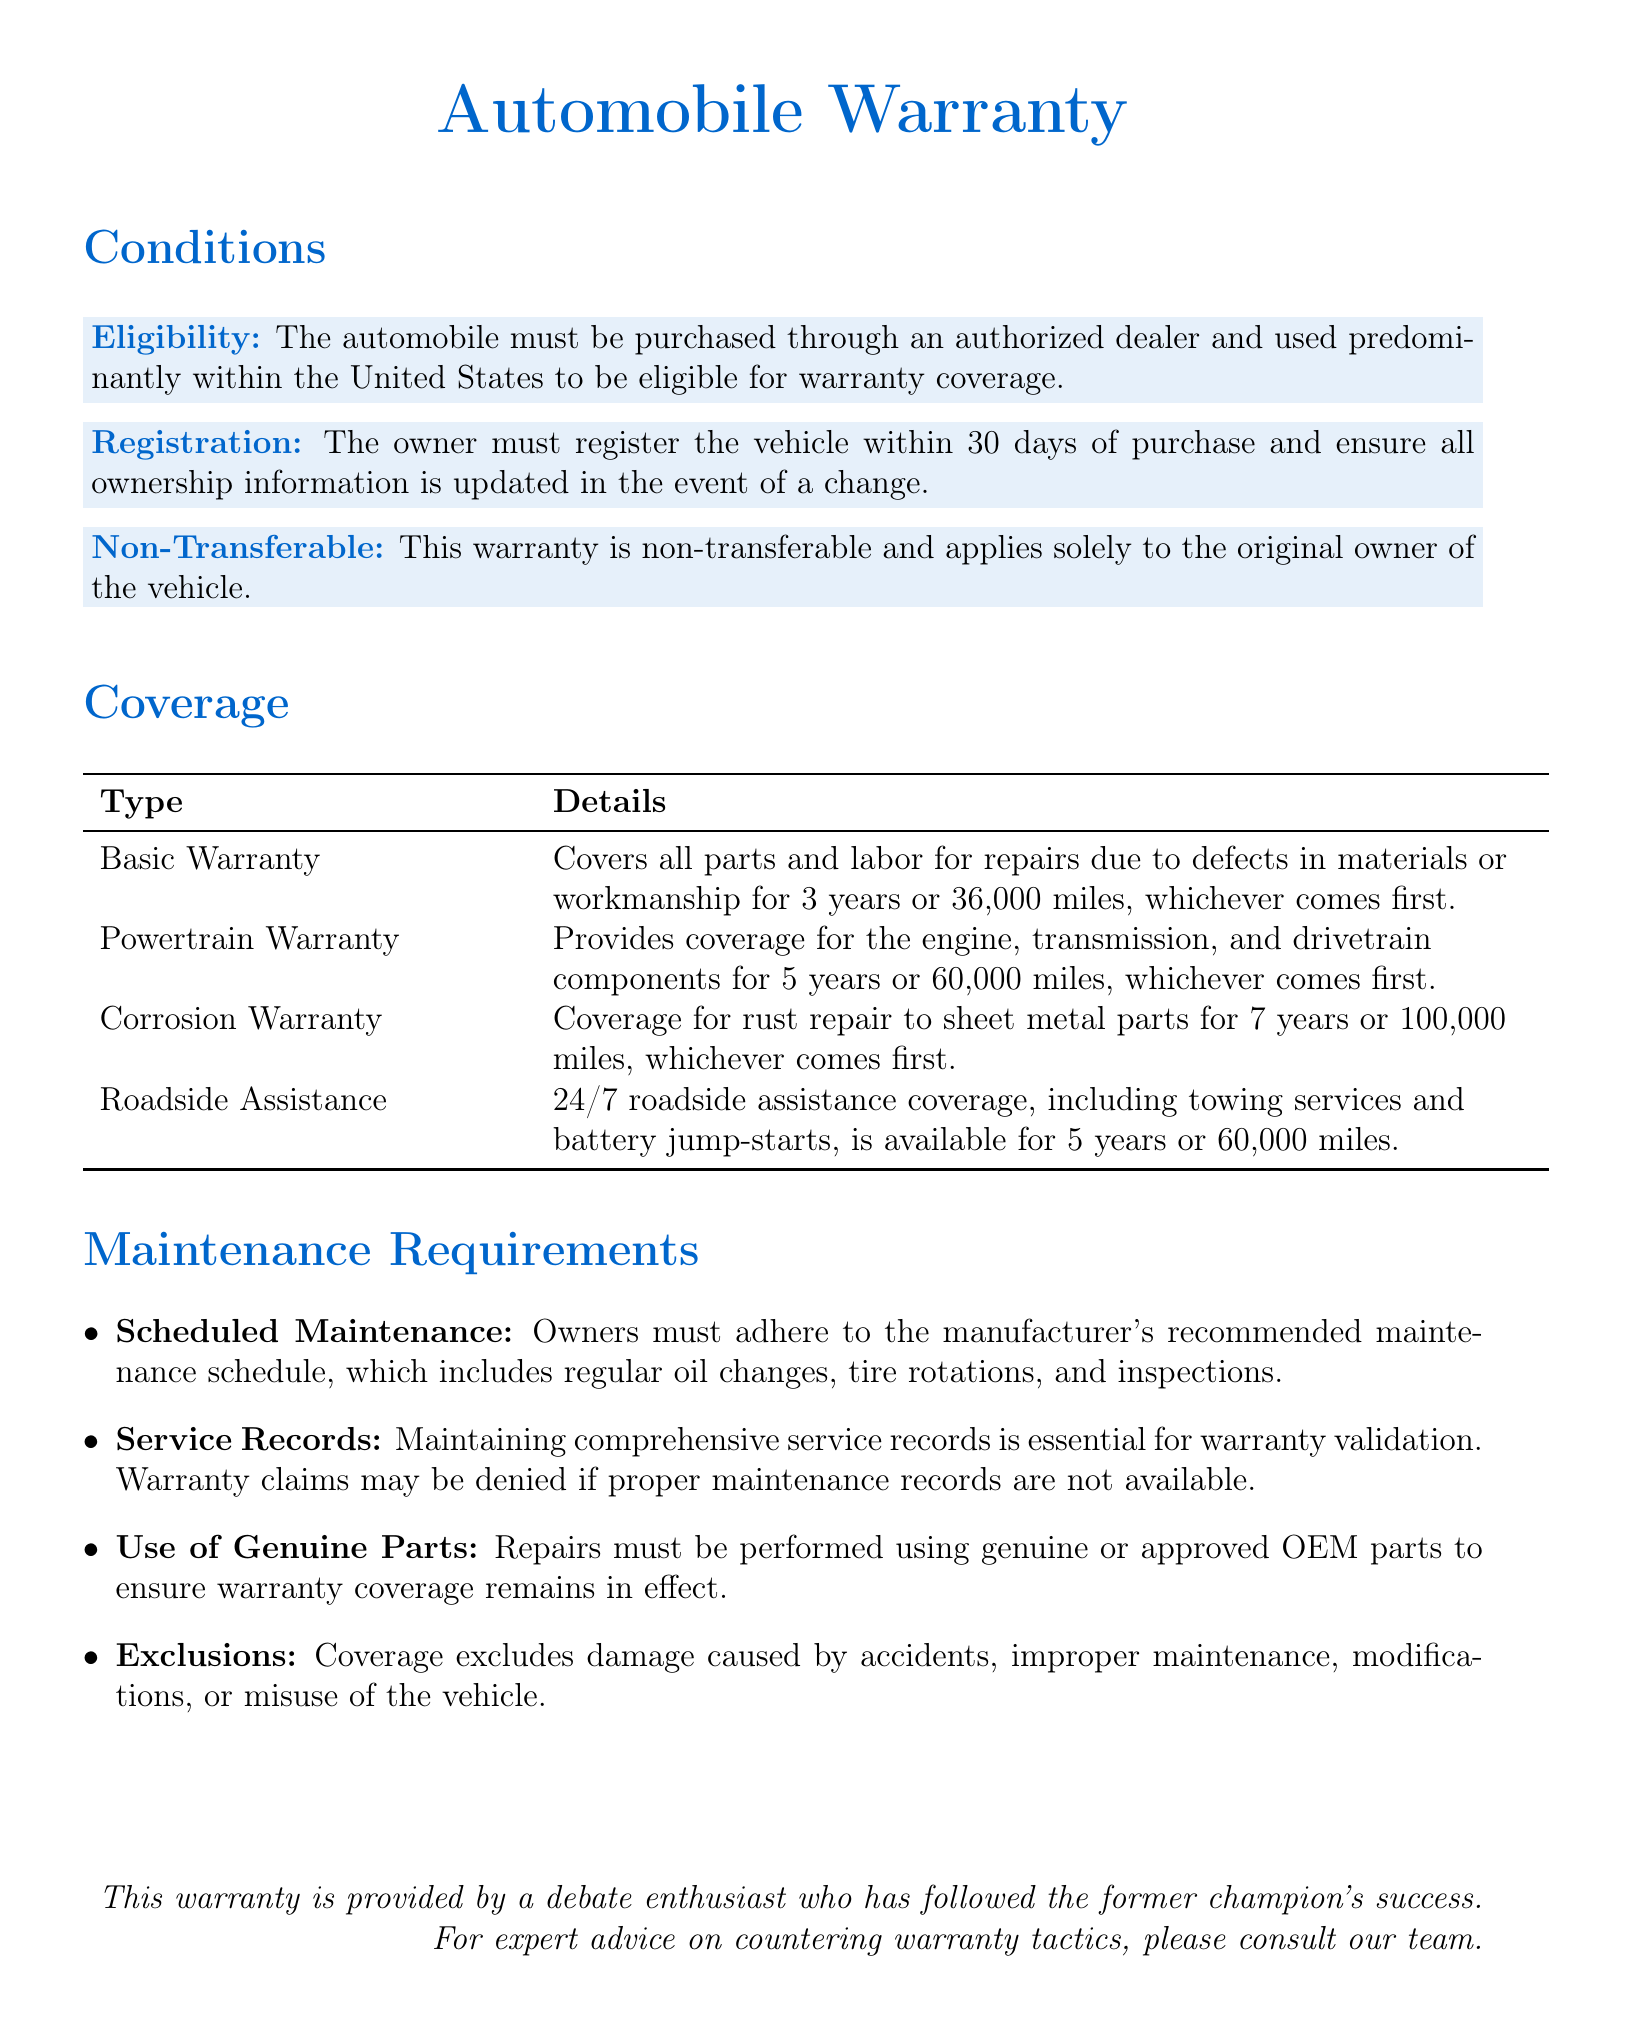What is the duration of the Basic Warranty? The Basic Warranty covers repairs due to defects for 3 years or 36,000 miles, whichever comes first.
Answer: 3 years or 36,000 miles What must the owner do within 30 days of purchase? The owner must register the vehicle within 30 days of purchase.
Answer: Register the vehicle What components are covered by the Powertrain Warranty? The Powertrain Warranty covers the engine, transmission, and drivetrain components.
Answer: Engine, transmission, and drivetrain What is required for warranty validation? Maintaining comprehensive service records is essential for warranty validation.
Answer: Service records How long is the Corrosion Warranty valid? The Corrosion Warranty covers rust repair for 7 years or 100,000 miles, whichever comes first.
Answer: 7 years or 100,000 miles What exclusions are listed under Maintenance Requirements? Coverage excludes damage caused by accidents, improper maintenance, modifications, or misuse of the vehicle.
Answer: Accidents, improper maintenance, modifications, misuse Is the warranty transferable to a new owner? The warranty is non-transferable and applies solely to the original owner of the vehicle.
Answer: Non-transferable How long does the Roadside Assistance last? Roadside Assistance is available for 5 years or 60,000 miles.
Answer: 5 years or 60,000 miles 